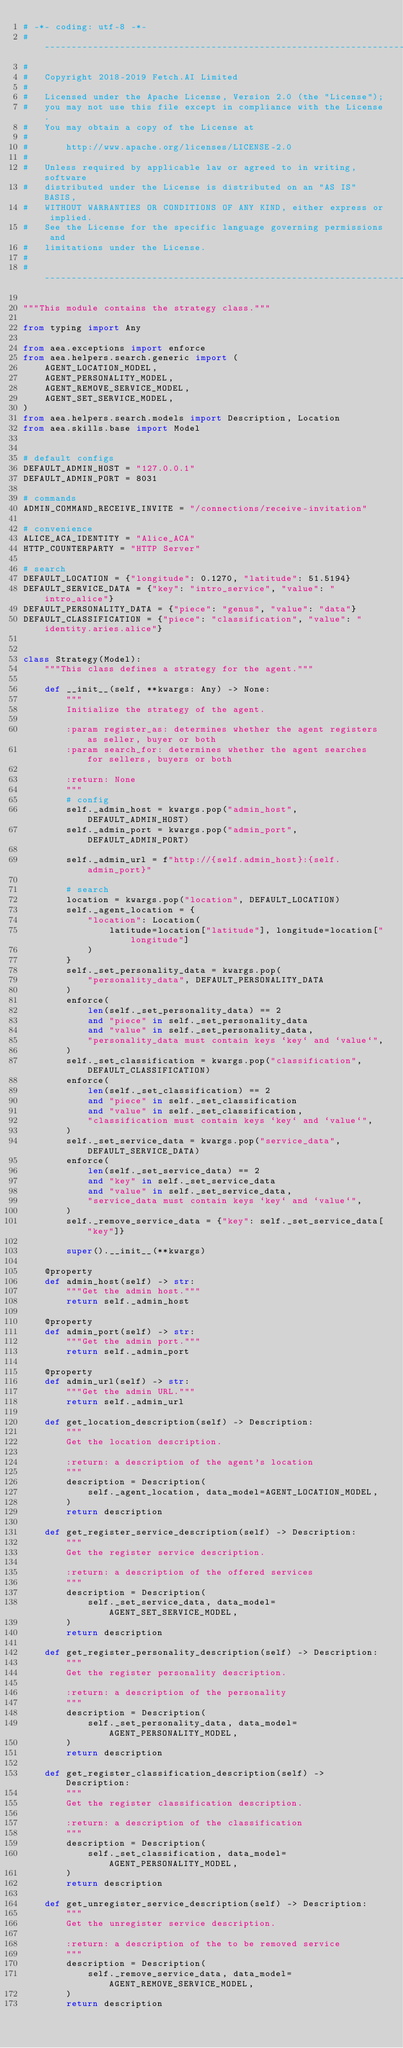Convert code to text. <code><loc_0><loc_0><loc_500><loc_500><_Python_># -*- coding: utf-8 -*-
# ------------------------------------------------------------------------------
#
#   Copyright 2018-2019 Fetch.AI Limited
#
#   Licensed under the Apache License, Version 2.0 (the "License");
#   you may not use this file except in compliance with the License.
#   You may obtain a copy of the License at
#
#       http://www.apache.org/licenses/LICENSE-2.0
#
#   Unless required by applicable law or agreed to in writing, software
#   distributed under the License is distributed on an "AS IS" BASIS,
#   WITHOUT WARRANTIES OR CONDITIONS OF ANY KIND, either express or implied.
#   See the License for the specific language governing permissions and
#   limitations under the License.
#
# ------------------------------------------------------------------------------

"""This module contains the strategy class."""

from typing import Any

from aea.exceptions import enforce
from aea.helpers.search.generic import (
    AGENT_LOCATION_MODEL,
    AGENT_PERSONALITY_MODEL,
    AGENT_REMOVE_SERVICE_MODEL,
    AGENT_SET_SERVICE_MODEL,
)
from aea.helpers.search.models import Description, Location
from aea.skills.base import Model


# default configs
DEFAULT_ADMIN_HOST = "127.0.0.1"
DEFAULT_ADMIN_PORT = 8031

# commands
ADMIN_COMMAND_RECEIVE_INVITE = "/connections/receive-invitation"

# convenience
ALICE_ACA_IDENTITY = "Alice_ACA"
HTTP_COUNTERPARTY = "HTTP Server"

# search
DEFAULT_LOCATION = {"longitude": 0.1270, "latitude": 51.5194}
DEFAULT_SERVICE_DATA = {"key": "intro_service", "value": "intro_alice"}
DEFAULT_PERSONALITY_DATA = {"piece": "genus", "value": "data"}
DEFAULT_CLASSIFICATION = {"piece": "classification", "value": "identity.aries.alice"}


class Strategy(Model):
    """This class defines a strategy for the agent."""

    def __init__(self, **kwargs: Any) -> None:
        """
        Initialize the strategy of the agent.

        :param register_as: determines whether the agent registers as seller, buyer or both
        :param search_for: determines whether the agent searches for sellers, buyers or both

        :return: None
        """
        # config
        self._admin_host = kwargs.pop("admin_host", DEFAULT_ADMIN_HOST)
        self._admin_port = kwargs.pop("admin_port", DEFAULT_ADMIN_PORT)

        self._admin_url = f"http://{self.admin_host}:{self.admin_port}"

        # search
        location = kwargs.pop("location", DEFAULT_LOCATION)
        self._agent_location = {
            "location": Location(
                latitude=location["latitude"], longitude=location["longitude"]
            )
        }
        self._set_personality_data = kwargs.pop(
            "personality_data", DEFAULT_PERSONALITY_DATA
        )
        enforce(
            len(self._set_personality_data) == 2
            and "piece" in self._set_personality_data
            and "value" in self._set_personality_data,
            "personality_data must contain keys `key` and `value`",
        )
        self._set_classification = kwargs.pop("classification", DEFAULT_CLASSIFICATION)
        enforce(
            len(self._set_classification) == 2
            and "piece" in self._set_classification
            and "value" in self._set_classification,
            "classification must contain keys `key` and `value`",
        )
        self._set_service_data = kwargs.pop("service_data", DEFAULT_SERVICE_DATA)
        enforce(
            len(self._set_service_data) == 2
            and "key" in self._set_service_data
            and "value" in self._set_service_data,
            "service_data must contain keys `key` and `value`",
        )
        self._remove_service_data = {"key": self._set_service_data["key"]}

        super().__init__(**kwargs)

    @property
    def admin_host(self) -> str:
        """Get the admin host."""
        return self._admin_host

    @property
    def admin_port(self) -> str:
        """Get the admin port."""
        return self._admin_port

    @property
    def admin_url(self) -> str:
        """Get the admin URL."""
        return self._admin_url

    def get_location_description(self) -> Description:
        """
        Get the location description.

        :return: a description of the agent's location
        """
        description = Description(
            self._agent_location, data_model=AGENT_LOCATION_MODEL,
        )
        return description

    def get_register_service_description(self) -> Description:
        """
        Get the register service description.

        :return: a description of the offered services
        """
        description = Description(
            self._set_service_data, data_model=AGENT_SET_SERVICE_MODEL,
        )
        return description

    def get_register_personality_description(self) -> Description:
        """
        Get the register personality description.

        :return: a description of the personality
        """
        description = Description(
            self._set_personality_data, data_model=AGENT_PERSONALITY_MODEL,
        )
        return description

    def get_register_classification_description(self) -> Description:
        """
        Get the register classification description.

        :return: a description of the classification
        """
        description = Description(
            self._set_classification, data_model=AGENT_PERSONALITY_MODEL,
        )
        return description

    def get_unregister_service_description(self) -> Description:
        """
        Get the unregister service description.

        :return: a description of the to be removed service
        """
        description = Description(
            self._remove_service_data, data_model=AGENT_REMOVE_SERVICE_MODEL,
        )
        return description
</code> 